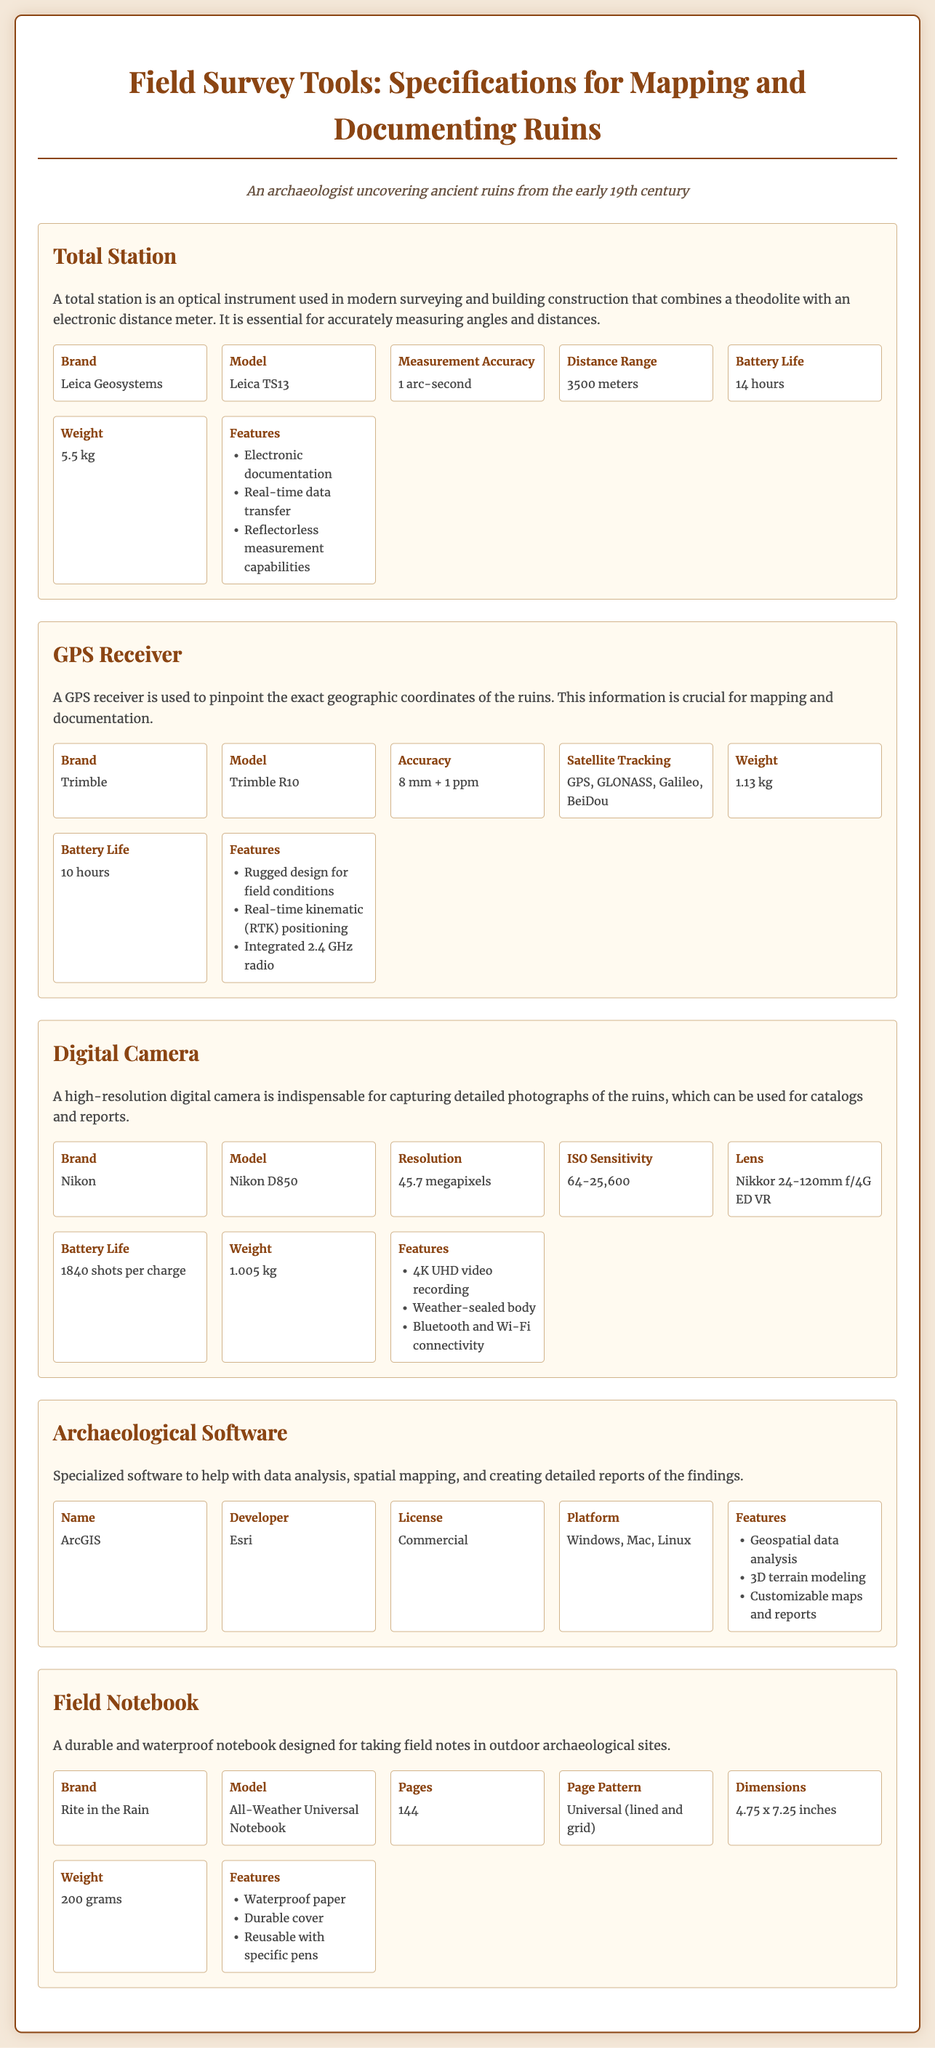What is the brand of the total station? The brand of the total station mentioned in the document is Leica Geosystems.
Answer: Leica Geosystems What is the resolution of the digital camera? The resolution of the Nikon D850 is stated in the document as 45.7 megapixels.
Answer: 45.7 megapixels What type of license does the archaeological software have? The document specifies that the license type for ArcGIS is Commercial.
Answer: Commercial What is the weight of the GPS receiver? The weight of the Trimble R10 GPS receiver is given as 1.13 kg.
Answer: 1.13 kg What is a key feature of the total station? One of the key features of the total station is Electronic documentation, as stated in the specifications.
Answer: Electronic documentation How many pages does the field notebook have? The number of pages in the Rite in the Rain All-Weather Universal Notebook is provided as 144.
Answer: 144 Which platforms support the archaeological software? The document lists the supported platforms for ArcGIS as Windows, Mac, and Linux.
Answer: Windows, Mac, Linux What is the measurement accuracy of the total station? The document details that the measurement accuracy of the Leica TS13 is 1 arc-second.
Answer: 1 arc-second What additional connectivity features does the digital camera have? The Nikon D850 digital camera includes Bluetooth and Wi-Fi connectivity as highlighted in the features.
Answer: Bluetooth and Wi-Fi connectivity 